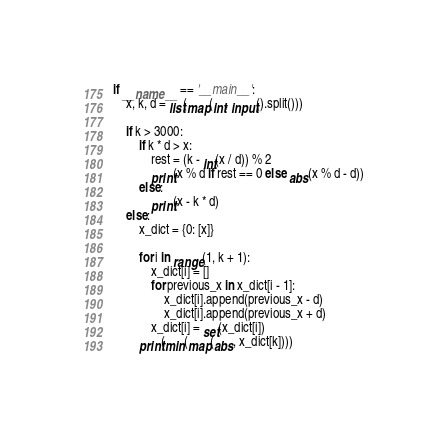Convert code to text. <code><loc_0><loc_0><loc_500><loc_500><_Python_>if __name__ == '__main__':
    x, k, d = list(map(int, input().split()))

    if k > 3000:
        if k * d > x:
            rest = (k - int(x / d)) % 2
            print(x % d if rest == 0 else abs(x % d - d))
        else:
            print(x - k * d)
    else:
        x_dict = {0: [x]}

        for i in range(1, k + 1):
            x_dict[i] = []
            for previous_x in x_dict[i - 1]:
                x_dict[i].append(previous_x - d)
                x_dict[i].append(previous_x + d)
            x_dict[i] = set(x_dict[i])
        print(min(map(abs, x_dict[k])))</code> 